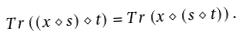<formula> <loc_0><loc_0><loc_500><loc_500>T r \left ( ( x \diamond s ) \diamond t \right ) = T r \left ( x \diamond ( s \diamond t ) \right ) .</formula> 